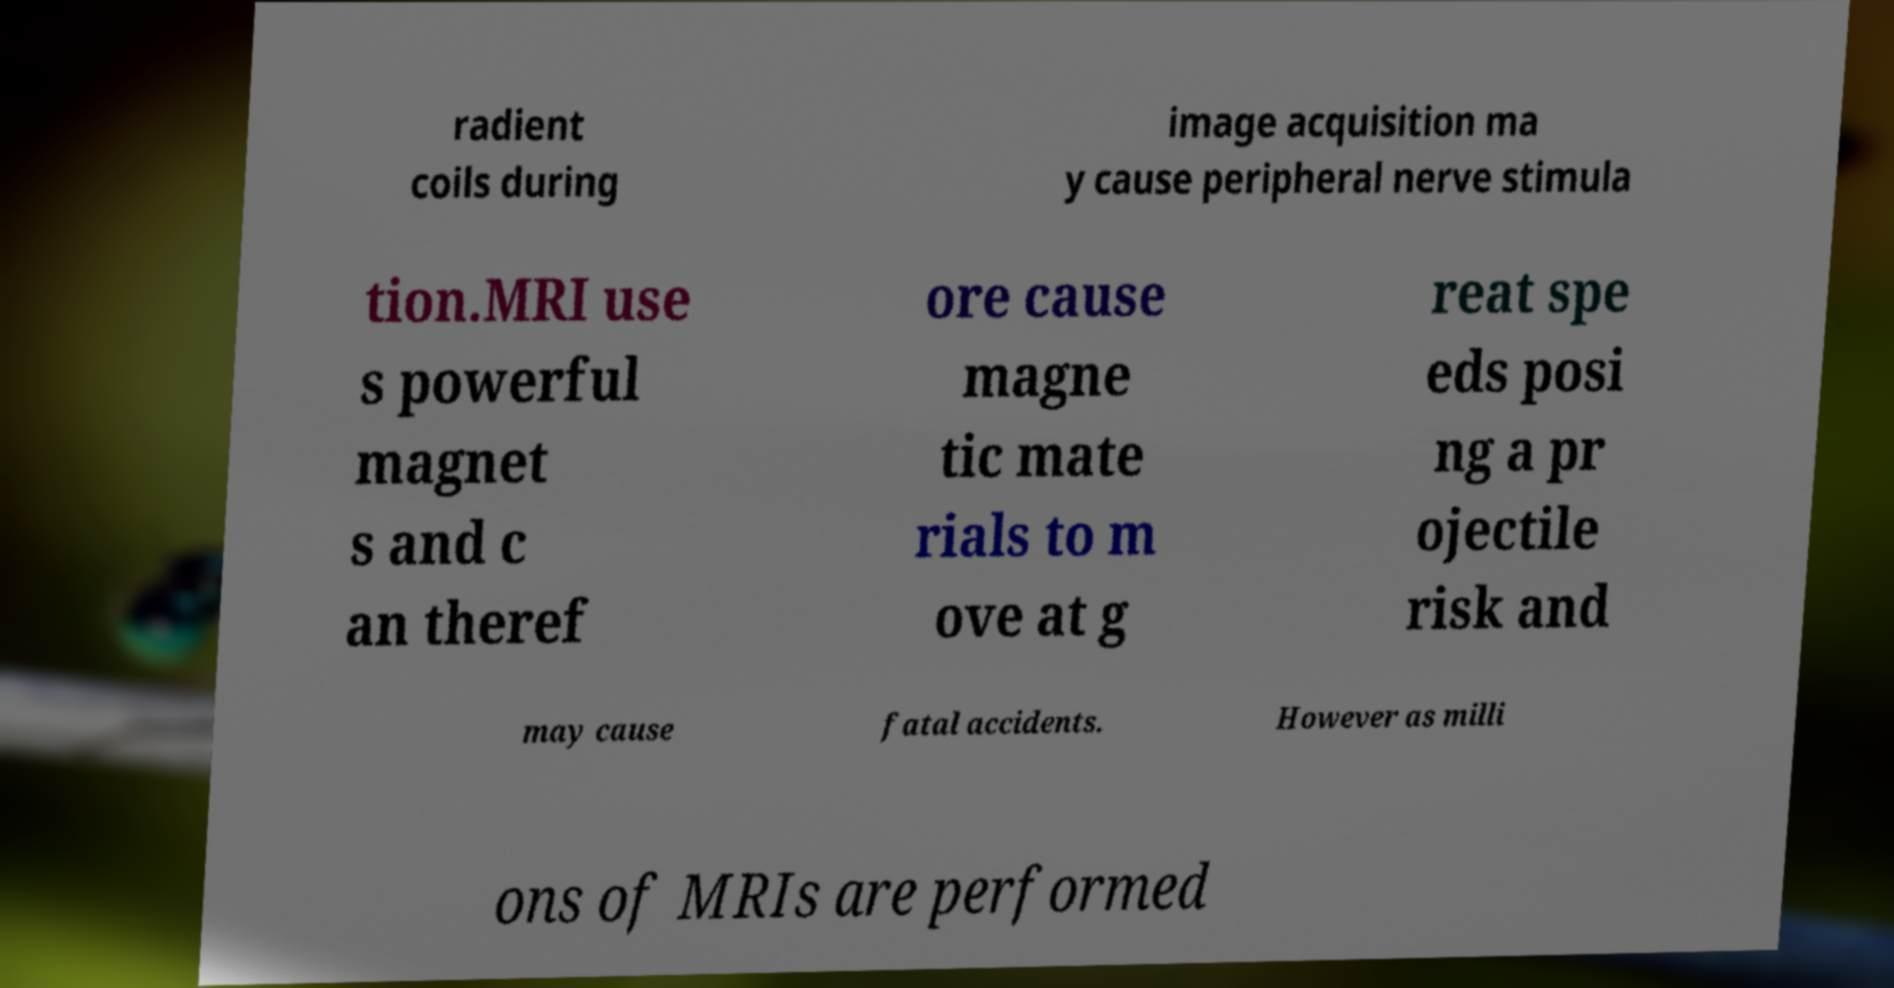Could you assist in decoding the text presented in this image and type it out clearly? radient coils during image acquisition ma y cause peripheral nerve stimula tion.MRI use s powerful magnet s and c an theref ore cause magne tic mate rials to m ove at g reat spe eds posi ng a pr ojectile risk and may cause fatal accidents. However as milli ons of MRIs are performed 